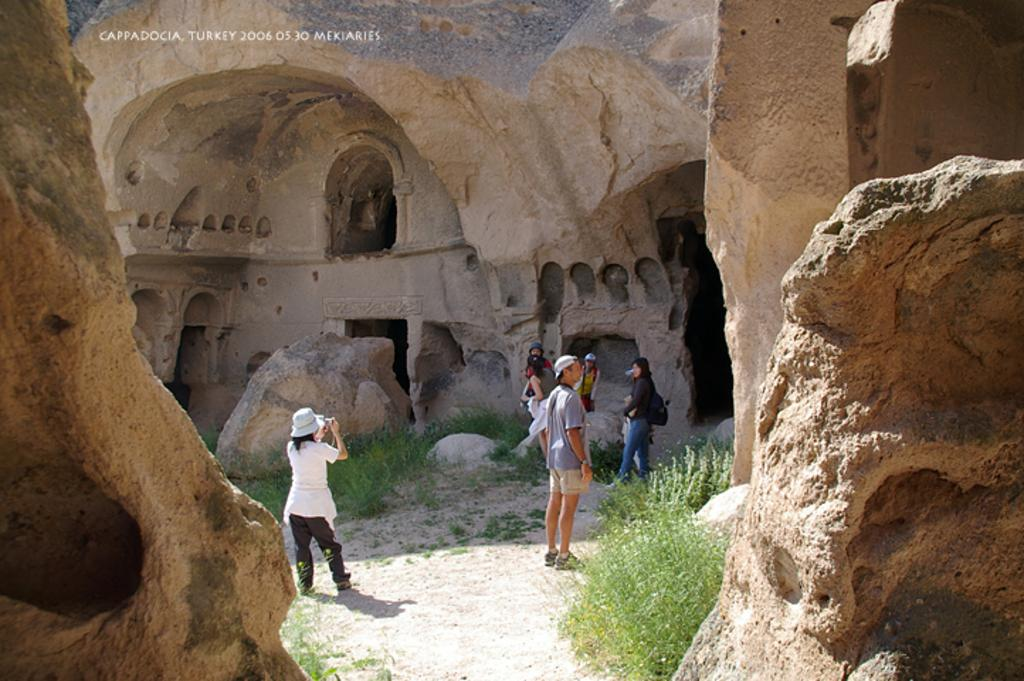Who is present in the image? There are tourists in the image. What are the tourists doing in the image? The tourists are visiting caves. Can you describe the woman in the image? There is a woman taking a photograph of the cave. What type of vegetation can be seen in the image? There is grass on the surface in the image. What caption is written on the photograph taken by the woman in the image? There is no caption visible in the image, as it only shows the woman taking a photograph of the cave. Can you see any friends of the tourists in the image? The provided facts do not mention any friends of the tourists, so we cannot determine if they are present in the image. 